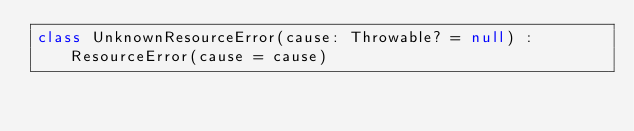Convert code to text. <code><loc_0><loc_0><loc_500><loc_500><_Kotlin_>class UnknownResourceError(cause: Throwable? = null) : ResourceError(cause = cause)</code> 